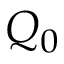Convert formula to latex. <formula><loc_0><loc_0><loc_500><loc_500>Q _ { 0 }</formula> 